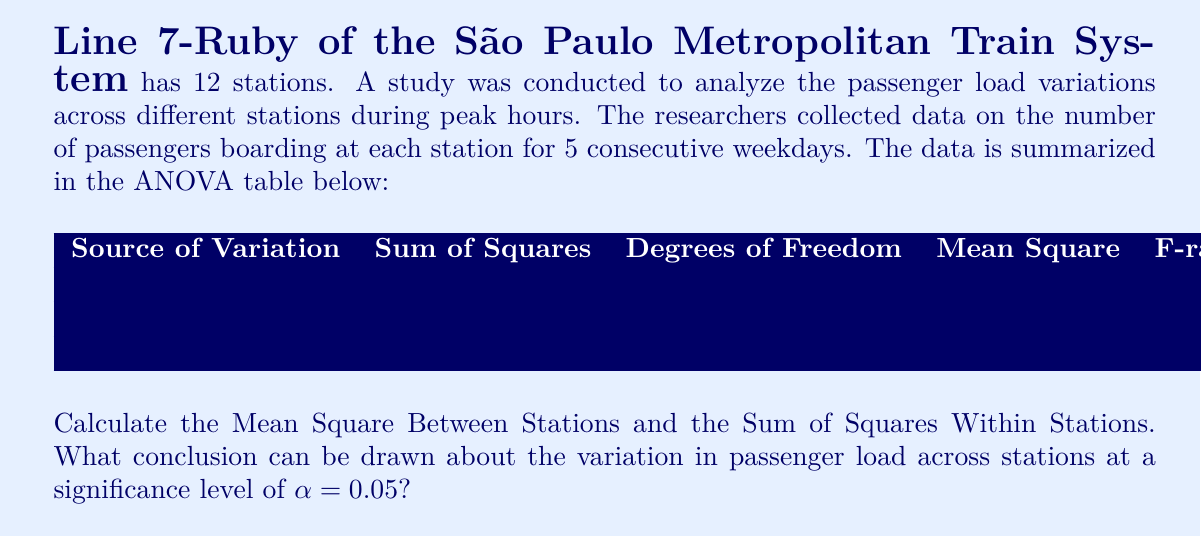Can you solve this math problem? Let's approach this step-by-step:

1) First, let's calculate the Mean Square Between Stations:
   We know that $F = \frac{MS_{between}}{MS_{within}}$
   $8.75 = \frac{MS_{between}}{200}$
   $MS_{between} = 8.75 \times 200 = 1750$

2) Now, let's calculate the Sum of Squares Within Stations:
   We know that $MS_{within} = \frac{SS_{within}}{df_{within}}$
   $200 = \frac{SS_{within}}{48}$
   $SS_{within} = 200 \times 48 = 9600$

3) To verify our calculations, we can check if the total Sum of Squares adds up:
   $SS_{total} = SS_{between} + SS_{within}$
   $27,900 = 24,500 + 9,600$
   This checks out.

4) To draw a conclusion, we need to compare the calculated F-ratio (8.75) with the critical F-value.
   For $\alpha = 0.05$, $df_{between} = 11$, and $df_{within} = 48$, the critical F-value is approximately 2.00.

5) Since our calculated F-ratio (8.75) is greater than the critical F-value (2.00), we reject the null hypothesis.

Conclusion: There is significant evidence to suggest that the passenger load varies across different stations on Line 7-Ruby during peak hours. This variation is statistically significant at the 0.05 level.
Answer: Mean Square Between Stations: 1750
Sum of Squares Within Stations: 9600
Conclusion: There is significant variation in passenger load across stations on Line 7-Ruby during peak hours (F(11,48) = 8.75, p < 0.05). 